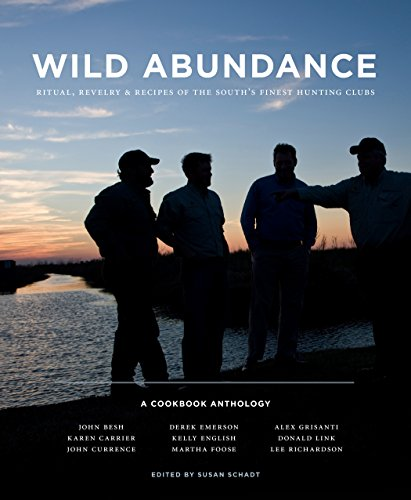What is the title of this book?
Answer the question using a single word or phrase. Wild Abundance: Ritual, Revelry & Recipes of the South's Finest Hunting Clubs What is the genre of this book? Cookbooks, Food & Wine Is this a recipe book? Yes Is this a historical book? No 